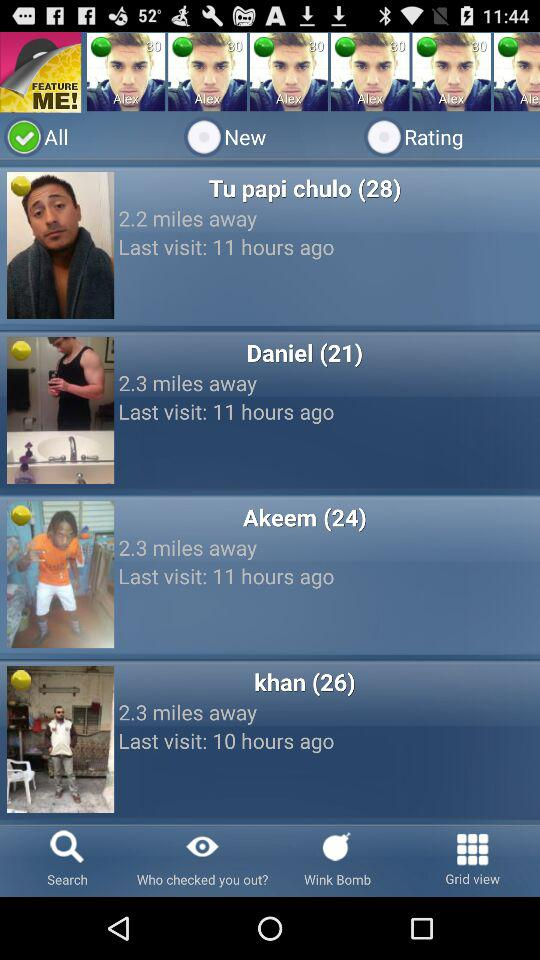What is the distance specified for Khan? The distance specified for Khan is 2.3 miles away. 